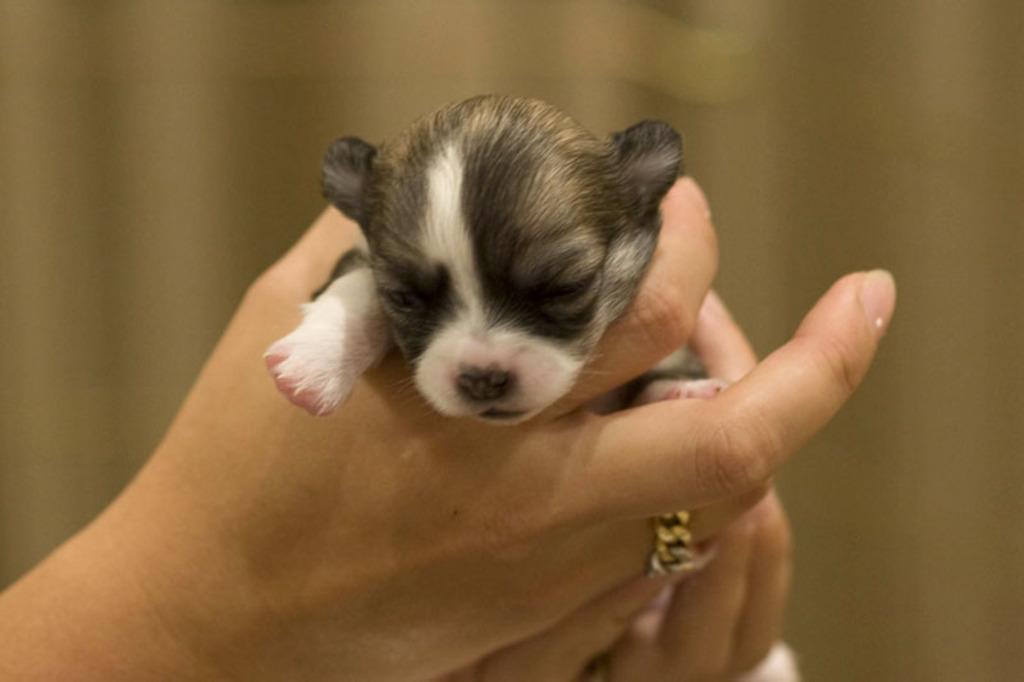In one or two sentences, can you explain what this image depicts? In this image I can see human hands holding a puppy which is black, brown and white in color. I can see the blurry background which is brown in color. 